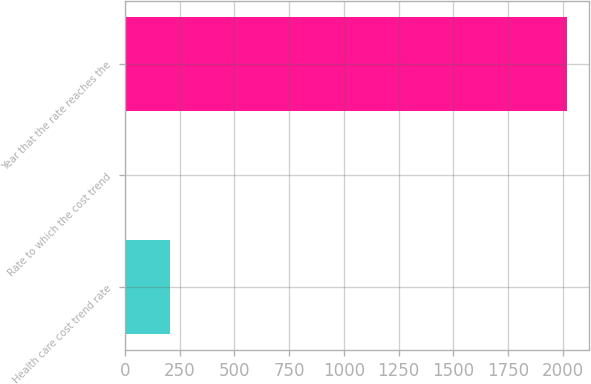Convert chart to OTSL. <chart><loc_0><loc_0><loc_500><loc_500><bar_chart><fcel>Health care cost trend rate<fcel>Rate to which the cost trend<fcel>Year that the rate reaches the<nl><fcel>205.95<fcel>4.5<fcel>2017<nl></chart> 